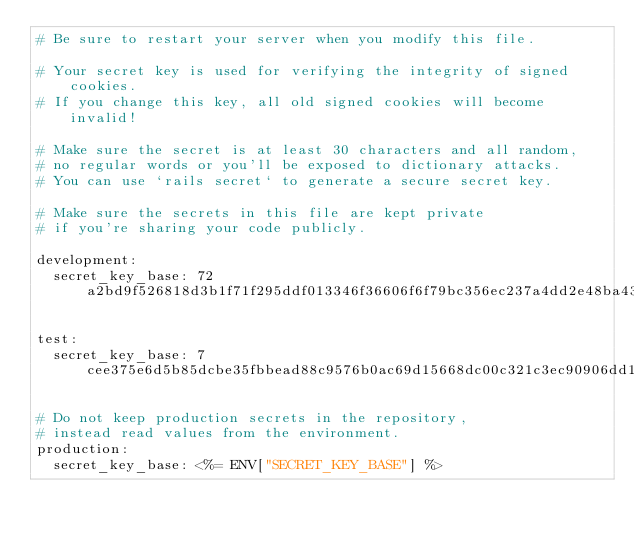Convert code to text. <code><loc_0><loc_0><loc_500><loc_500><_YAML_># Be sure to restart your server when you modify this file.

# Your secret key is used for verifying the integrity of signed cookies.
# If you change this key, all old signed cookies will become invalid!

# Make sure the secret is at least 30 characters and all random,
# no regular words or you'll be exposed to dictionary attacks.
# You can use `rails secret` to generate a secure secret key.

# Make sure the secrets in this file are kept private
# if you're sharing your code publicly.

development:
  secret_key_base: 72a2bd9f526818d3b1f71f295ddf013346f36606f6f79bc356ec237a4dd2e48ba431587ae5878f033780e7be59f5336ff60a5ccc85802eea197a7c4956d9ed27

test:
  secret_key_base: 7cee375e6d5b85dcbe35fbbead88c9576b0ac69d15668dc00c321c3ec90906dd10269b23f20e2c1c5a4aa69893fbfaf7d3a8171f263818fd476b6014ea50fbf2

# Do not keep production secrets in the repository,
# instead read values from the environment.
production:
  secret_key_base: <%= ENV["SECRET_KEY_BASE"] %>
</code> 